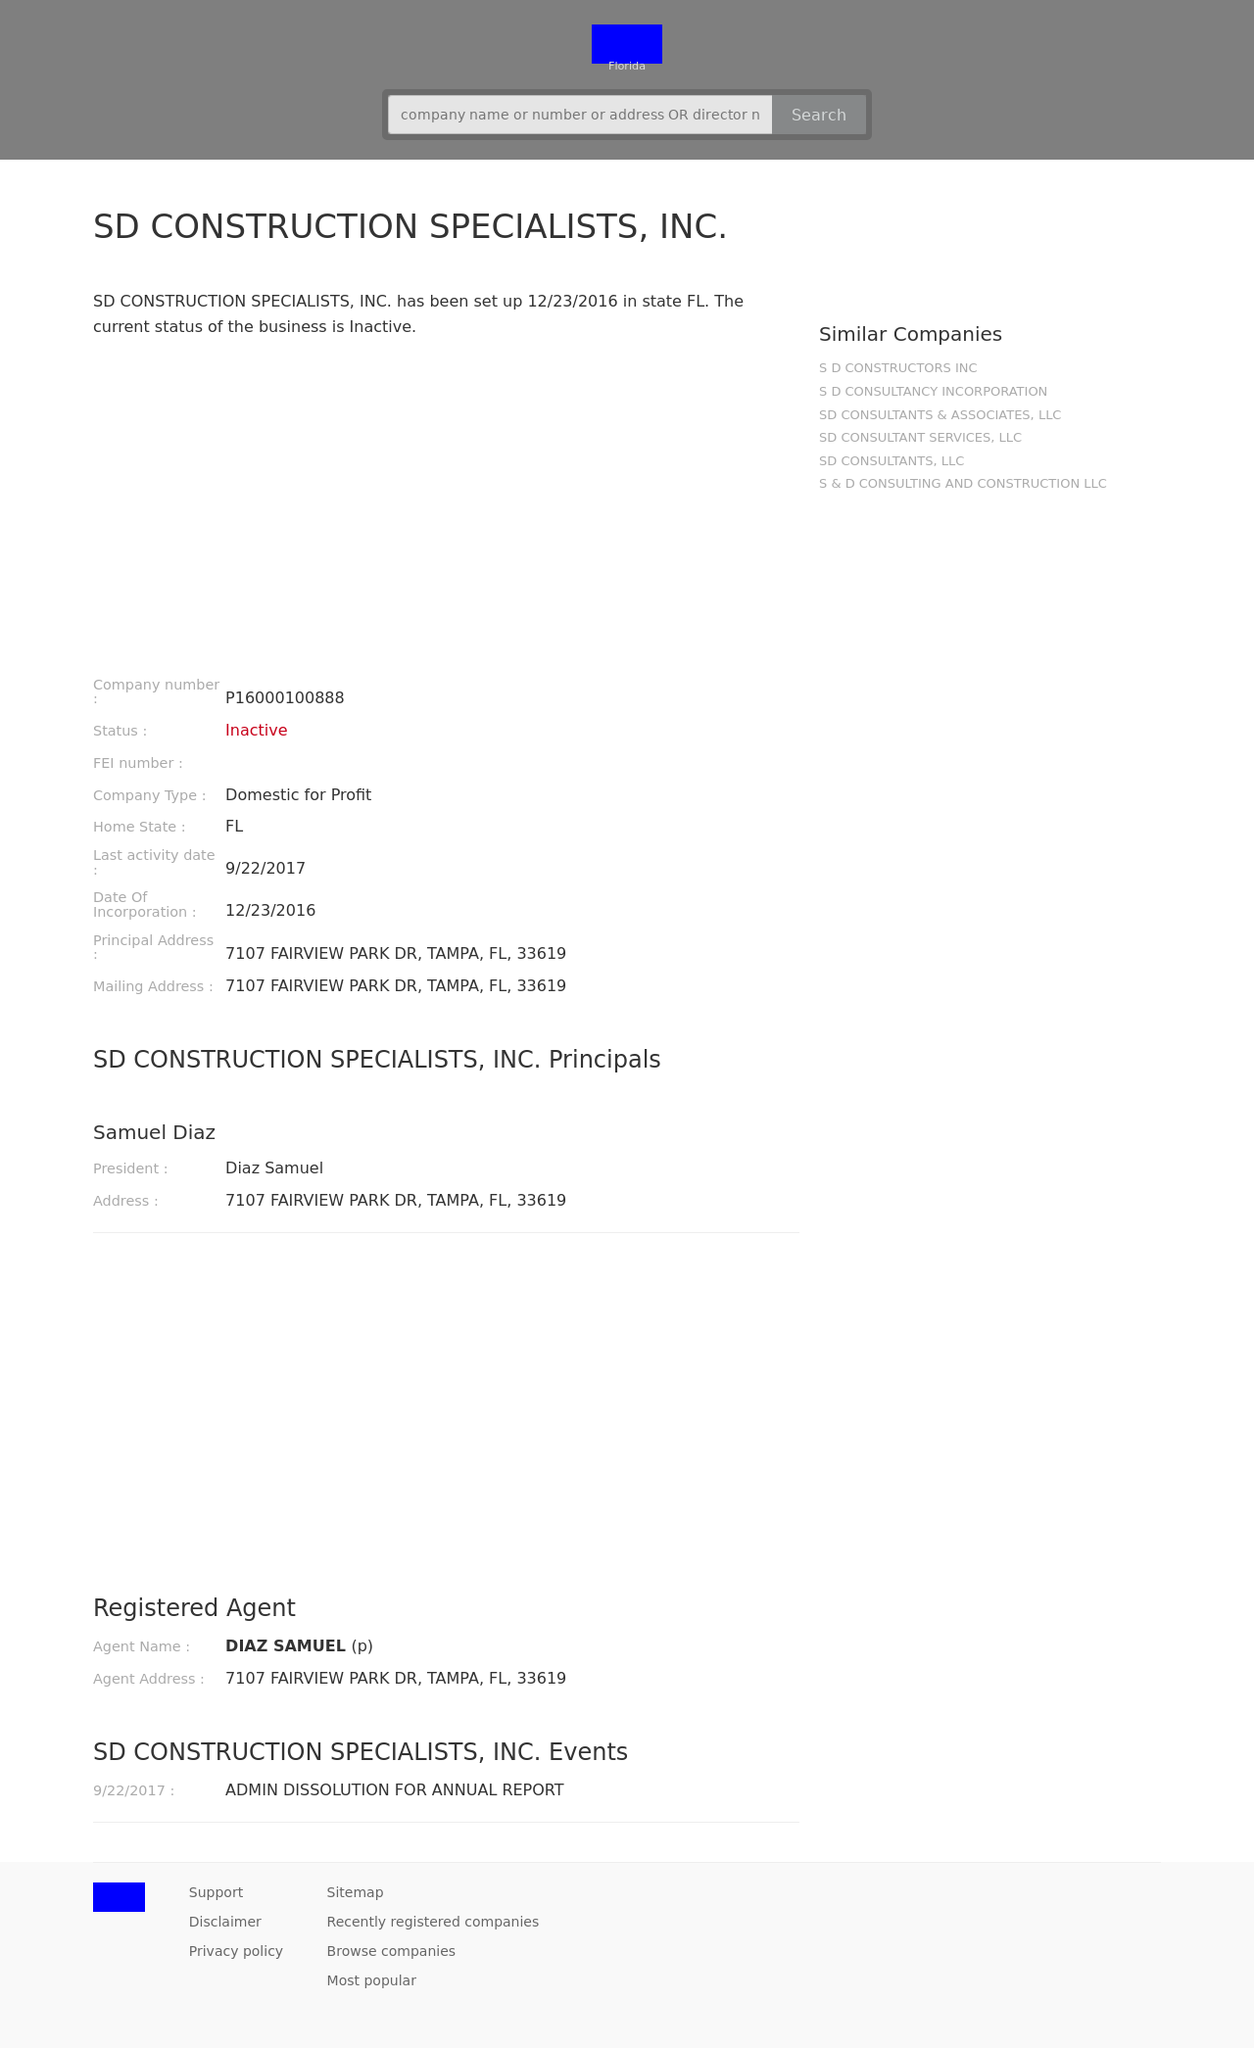Could you suggest how to make this website more mobile-friendly? To make the website more mobile-friendly, ensure it is responsive by using flexible layouts, images, and CSS media queries. These adjustments help the site adapt to different screen sizes from desktops to smartphones. Adding a viewport meta tag in the HTML head section is crucial for proper scaling and accessibility on mobile devices. Also, prioritize mobile navigation strategies, such as a hamburger menu for smaller screens to improve user navigation and experience. 